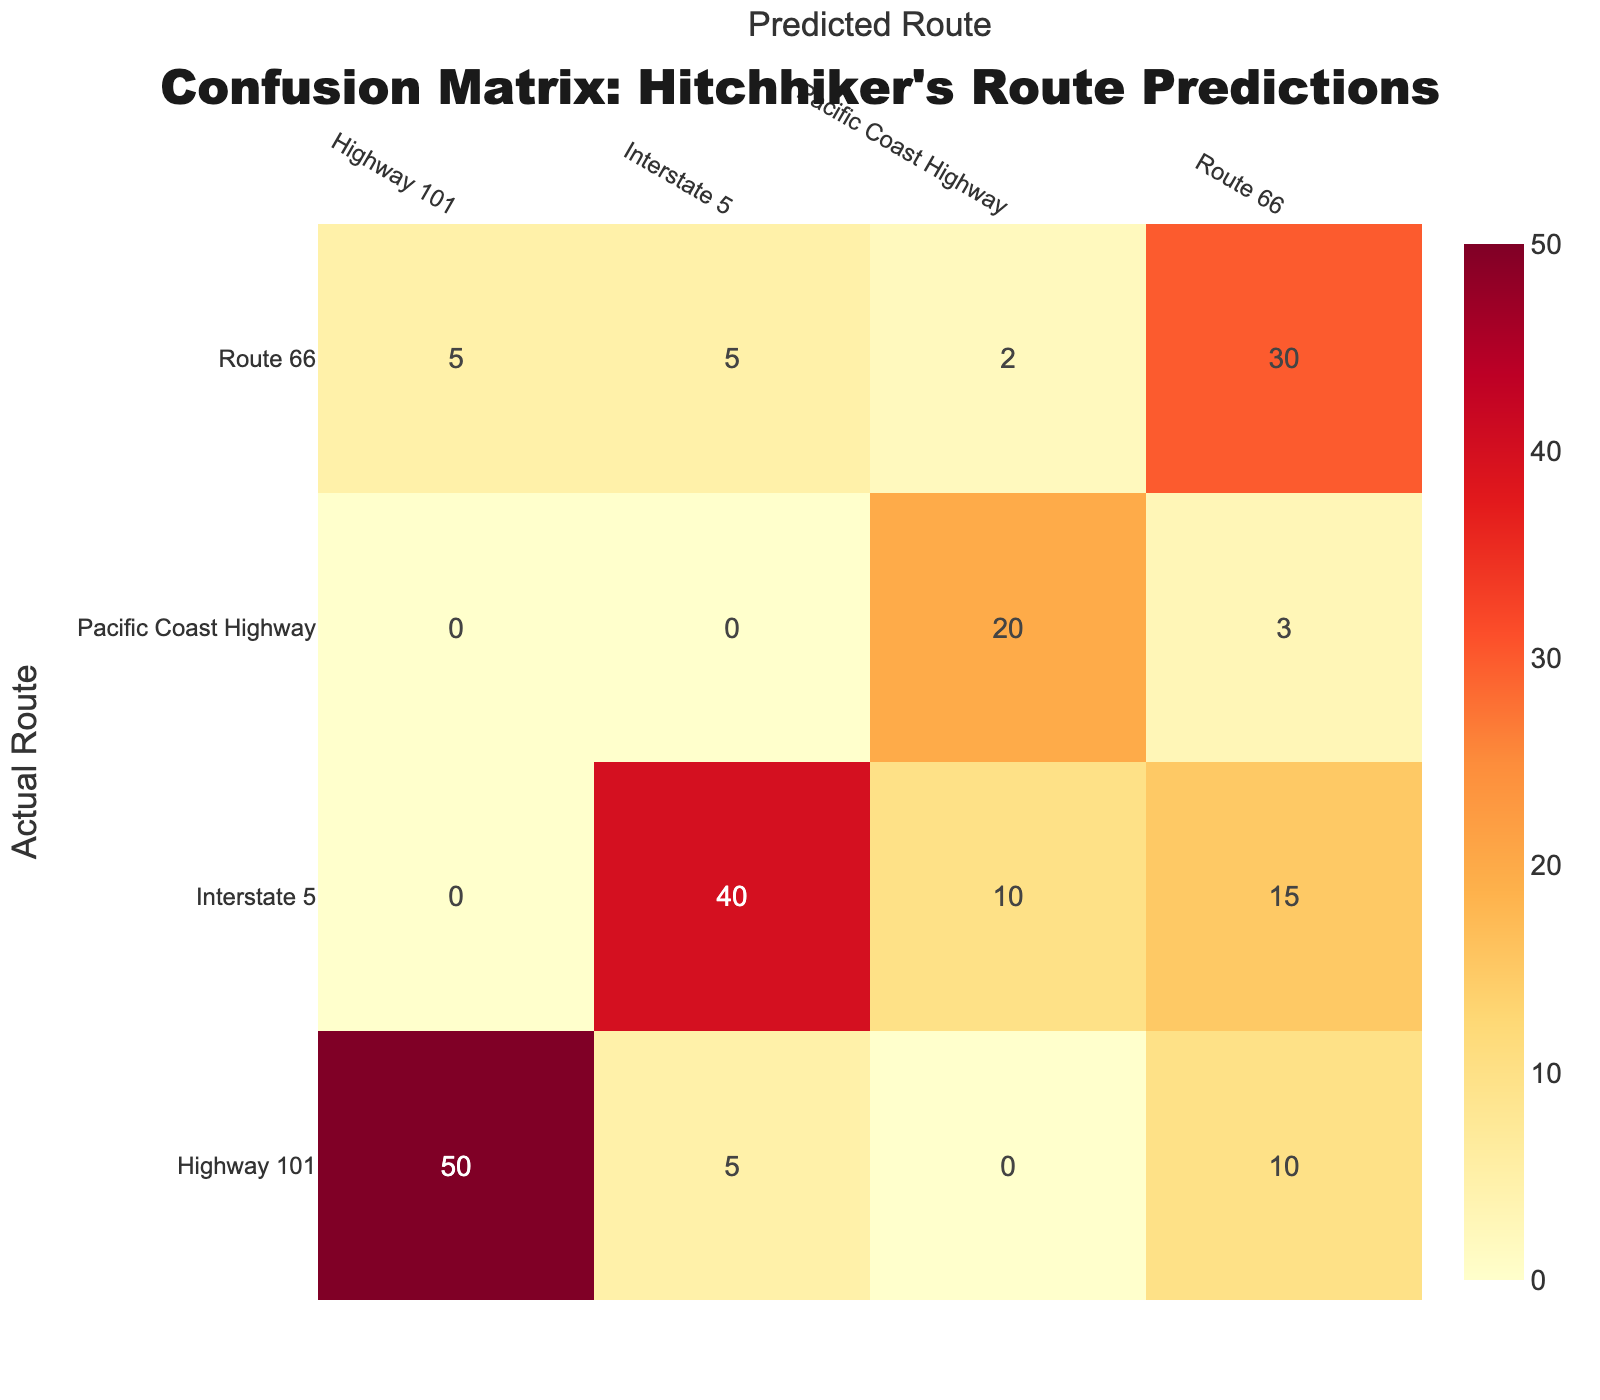What is the count of predictions for the actual route "Highway 101"? The table shows that for the actual route "Highway 101", there are two predictions: for "Highway 101" it is 50, and for "Route 66" it is 10. Thus, the total count is 50 + 10 = 60.
Answer: 60 What is the total count of predictions for the "Route 66"? For "Route 66", the table indicates three predictions: for "Route 66" it is 30, for "Highway 101" it is 5, and for "Pacific Coast Highway" it is 2, as well as for "Interstate 5" it is 5. Adding these together gives us 30 + 5 + 2 + 5 = 42.
Answer: 42 Is there any prediction count that is equal to 3? Upon reviewing the table, there is a count of 3 predictions for "Pacific Coast Highway" predicted as "Route 66". Therefore, the statement is true.
Answer: Yes Which actual route has the highest count of correctly predicted routes? Looking at the diagonal of the table, "Highway 101" has 50 correctly predicted routes, "Route 66" has 30, "Interstate 5" has 40, and "Pacific Coast Highway" has 20. "Highway 101" has the highest count of 50.
Answer: Highway 101 What is the combined count of predictions for "Interstate 5" as predicted by both "Route 66" and "Pacific Coast Highway"? In the table, "Interstate 5" has 15 predicted as "Route 66" and 10 predicted as "Pacific Coast Highway". Summing these gives 15 + 10 = 25.
Answer: 25 What is the ratio of correct predictions for "Interstate 5" compared to total predictions it received? The correct predictions for "Interstate 5" are 40, while the total predictions include those for "Route 66" (15) and "Pacific Coast Highway" (10), adding up to 40 + 15 + 10 = 65. The ratio is 40:65 which reduces to 8:13.
Answer: 8:13 How many more predictions were made for "Highway 101" than for "Pacific Coast Highway"? "Highway 101" received a total of 60 predictions (50 for its own and 10 for "Route 66"). "Pacific Coast Highway" had a total of 23 predictions (20 for itself, 3 for "Route 66", and 0 for others). The difference in predictions is 60 - 23 = 37.
Answer: 37 Is the count of incorrectly predicted routes for "Route 66" greater than that for "Highway 101"? The incorrectly predicted routes for "Route 66" can be calculated from those predicted incorrectly, which is for "Highway 101" (5) and "Interstate 5" (5). So total incorrect is 5 + 5 = 10. For "Highway 101," the incorrectly predicted routes are for "Route 66" (10) and "Interstate 5" (5), totaling 15. Therefore, the count for "Route 66" (10) is not greater than "Highway 101" (15).
Answer: No 